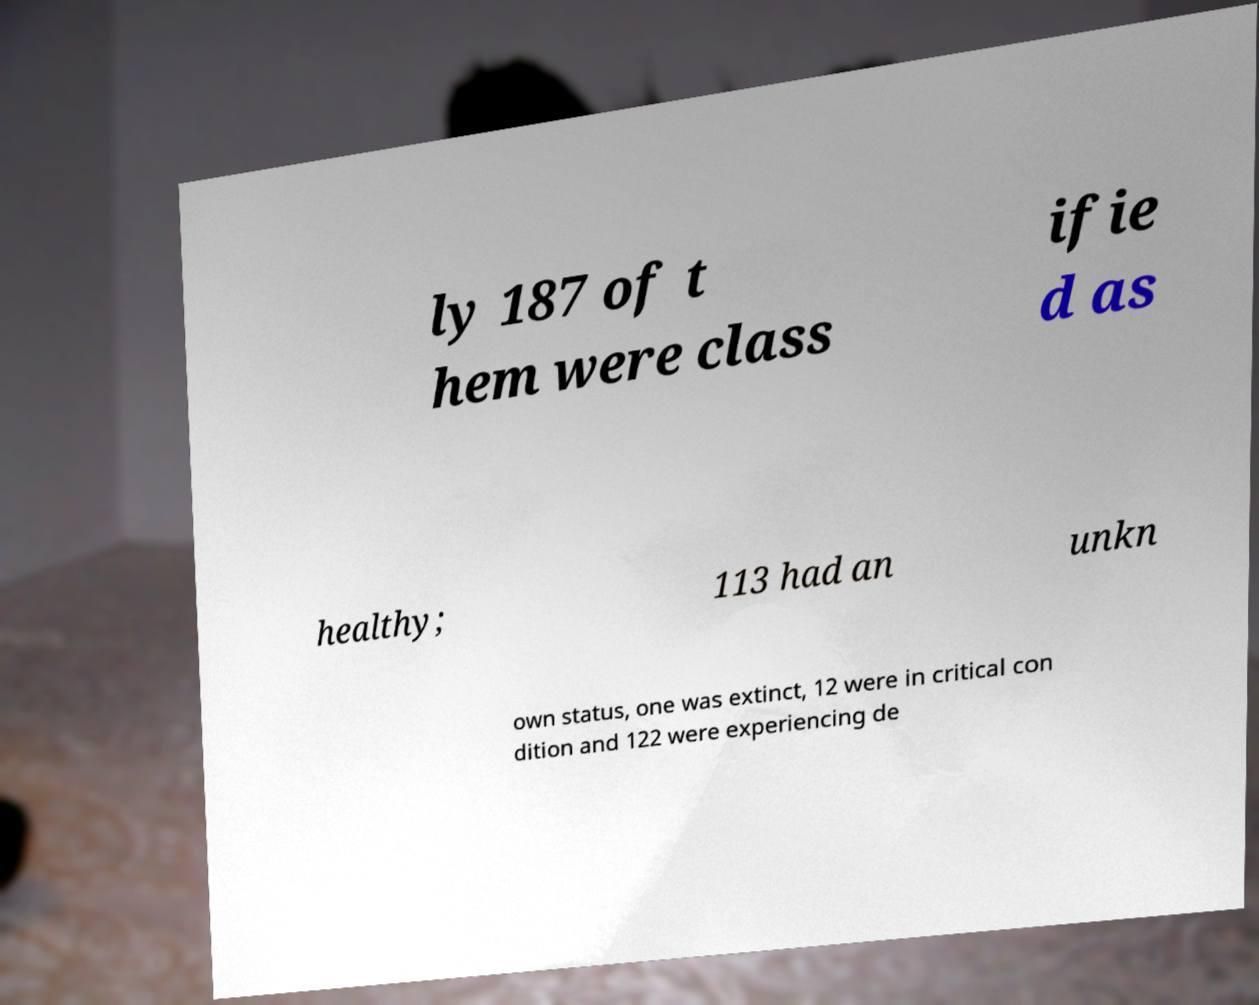Please read and relay the text visible in this image. What does it say? ly 187 of t hem were class ifie d as healthy; 113 had an unkn own status, one was extinct, 12 were in critical con dition and 122 were experiencing de 